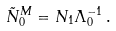<formula> <loc_0><loc_0><loc_500><loc_500>\tilde { N } _ { 0 } ^ { M } = N _ { 1 } \Lambda _ { 0 } ^ { - 1 } \, .</formula> 